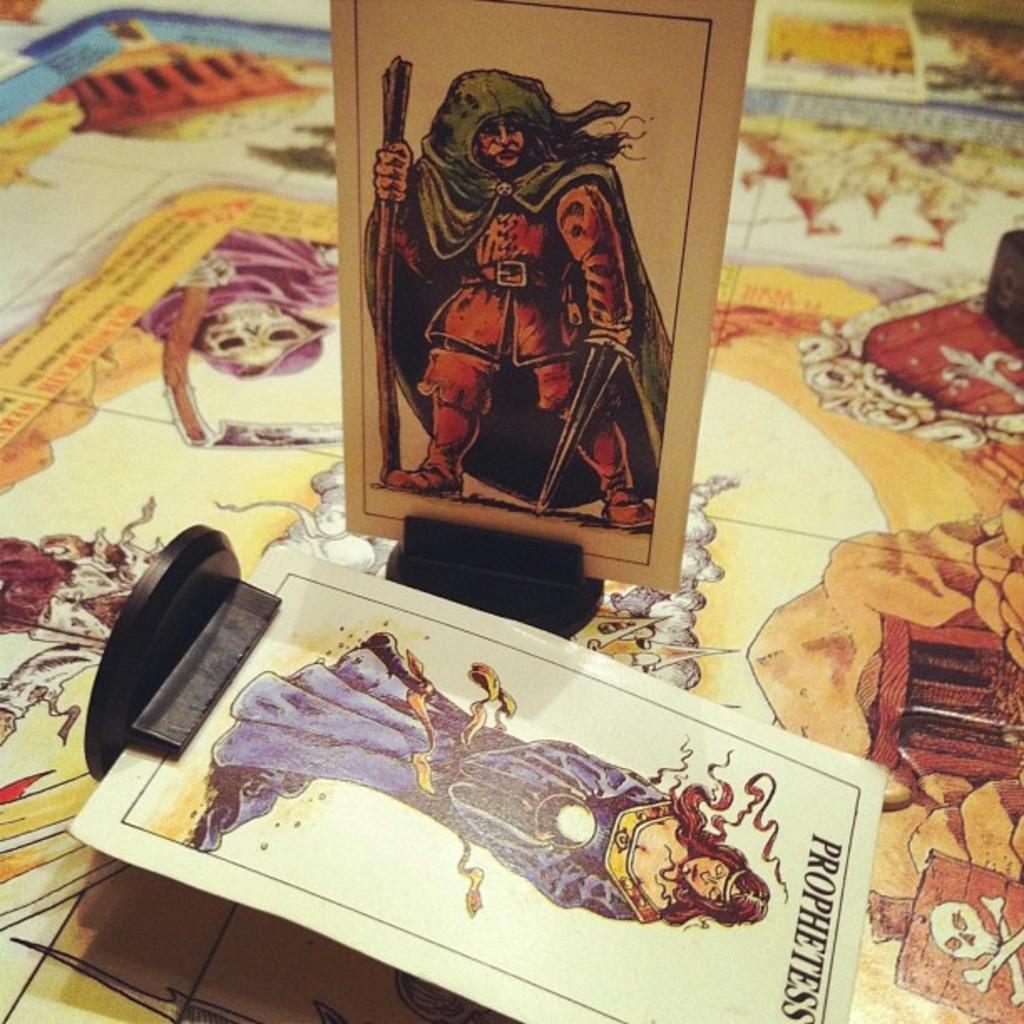Can you describe this image briefly? In this image, we can see image cards with stand on the poster. On the poster, we can see few images and text. 